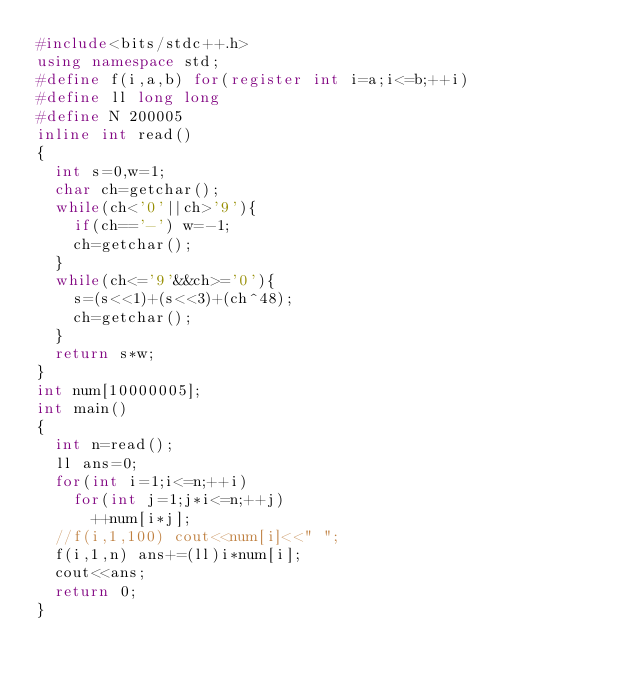Convert code to text. <code><loc_0><loc_0><loc_500><loc_500><_C++_>#include<bits/stdc++.h>
using namespace std;
#define f(i,a,b) for(register int i=a;i<=b;++i)
#define ll long long
#define N 200005
inline int read()
{
	int s=0,w=1;
	char ch=getchar();
	while(ch<'0'||ch>'9'){
		if(ch=='-') w=-1;
		ch=getchar();
	}
	while(ch<='9'&&ch>='0'){
		s=(s<<1)+(s<<3)+(ch^48);
		ch=getchar();
	}
	return s*w;
}
int num[10000005];
int main()
{
	int n=read();
	ll ans=0;
	for(int i=1;i<=n;++i)
		for(int j=1;j*i<=n;++j)
			++num[i*j];
	//f(i,1,100) cout<<num[i]<<" ";
	f(i,1,n) ans+=(ll)i*num[i];
	cout<<ans;
	return 0;
}</code> 